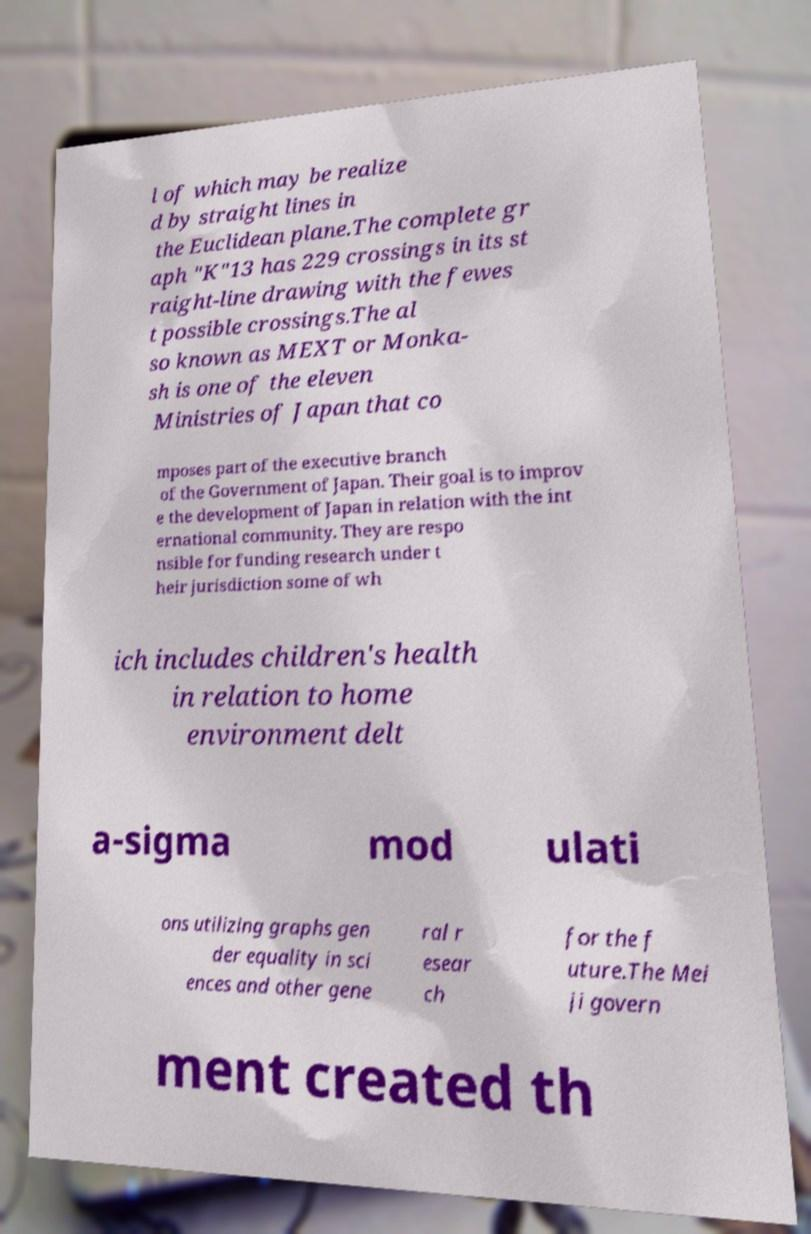What messages or text are displayed in this image? I need them in a readable, typed format. l of which may be realize d by straight lines in the Euclidean plane.The complete gr aph "K"13 has 229 crossings in its st raight-line drawing with the fewes t possible crossings.The al so known as MEXT or Monka- sh is one of the eleven Ministries of Japan that co mposes part of the executive branch of the Government of Japan. Their goal is to improv e the development of Japan in relation with the int ernational community. They are respo nsible for funding research under t heir jurisdiction some of wh ich includes children's health in relation to home environment delt a-sigma mod ulati ons utilizing graphs gen der equality in sci ences and other gene ral r esear ch for the f uture.The Mei ji govern ment created th 